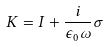Convert formula to latex. <formula><loc_0><loc_0><loc_500><loc_500>K = I + \frac { i } { \epsilon _ { 0 } \omega } \sigma</formula> 